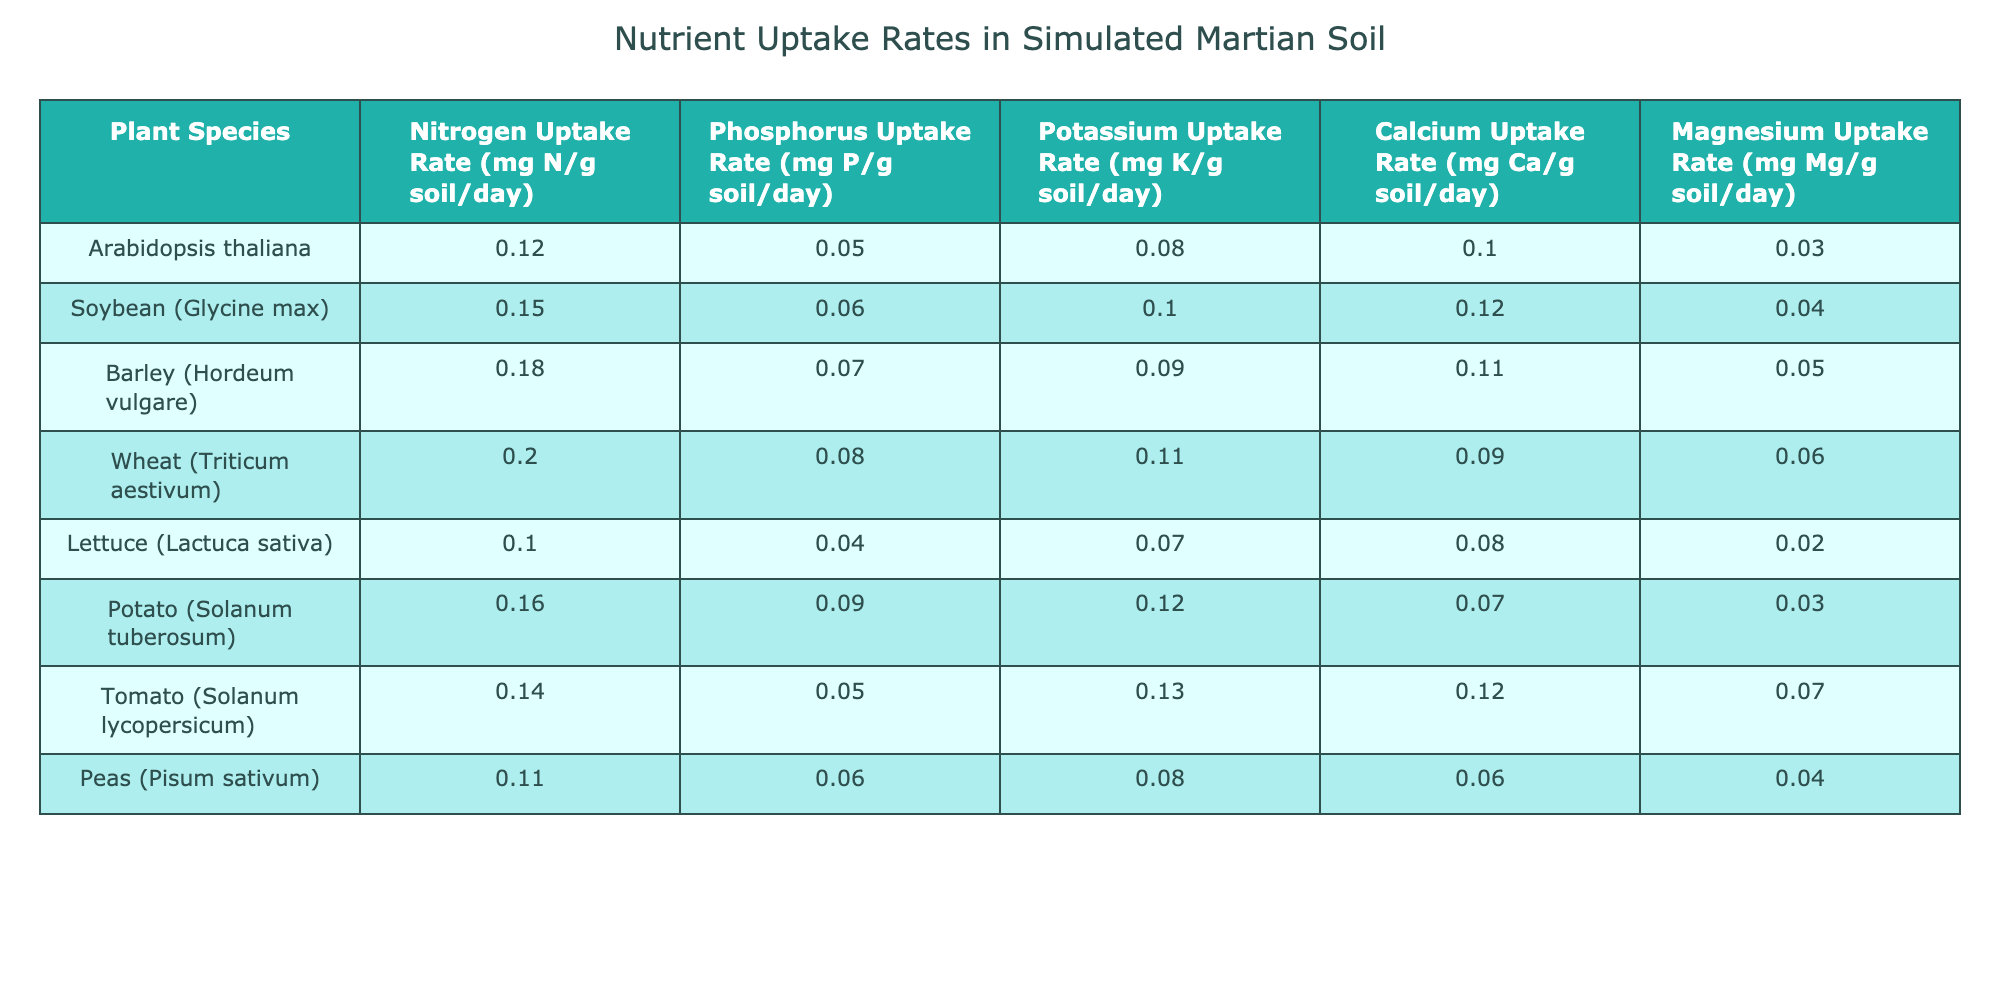What is the Nitrogen Uptake Rate for Wheat? The table lists the Nitrogen Uptake Rate for each plant species. For Wheat, the value provided is 0.20 mg N/g soil/day.
Answer: 0.20 mg N/g soil/day Which plant species has the highest Potassium Uptake Rate? By comparing the Potassium Uptake Rates in the table, Barley has the highest value at 0.09 mg K/g soil/day.
Answer: Barley What is the average Phosphorus Uptake Rate across all plant species? The Phosphorus Uptake Rate values are 0.05, 0.06, 0.07, 0.08, 0.04, 0.09, 0.05, and 0.06 mg P/g soil/day for the eight species. The total is 0.50 mg P/g soil/day, and dividing by 8 gives an average of 0.0625 mg P/g soil/day.
Answer: 0.0625 mg P/g soil/day Is the Calcium Uptake Rate for Tomato greater than that of Potato? The Calcium Uptake Rate for Tomato is 0.12 mg Ca/g soil/day, and for Potato, it is 0.07 mg Ca/g soil/day. Since 0.12 is greater than 0.07, the statement is true.
Answer: Yes If we combine the Nitrogen Uptake Rates of Soybean, Barley, and Potato, what is the total? The Nitrogen Uptake Rates for Soybean, Barley, and Potato are 0.15, 0.18, and 0.16 mg N/g soil/day, respectively. Summing these gives 0.15 + 0.18 + 0.16 = 0.49 mg N/g soil/day.
Answer: 0.49 mg N/g soil/day What is the difference in Magnesium Uptake Rate between Wheat and Potato? The Magnesium Uptake Rate for Wheat is 0.06 mg Mg/g soil/day and for Potato, it is 0.03 mg Mg/g soil/day. The difference is calculated as 0.06 - 0.03 = 0.03 mg Mg/g soil/day.
Answer: 0.03 mg Mg/g soil/day Do all plant species have a Nitrogen Uptake Rate greater than 0.10 mg N/g soil/day? The table shows that Arabidopsis thaliana and Peas have Nitrogen Uptake Rates of 0.12 and 0.11 mg N/g soil/day, respectively, which are greater than 0.10 mg N/g soil/day, but Lettuce only has 0.10 mg N/g soil/day, so the answer is no, not all.
Answer: No Which plant has the highest Magnesium Uptake Rate? The Magnesium Uptake Rates in the table are 0.03, 0.04, 0.05, 0.06, 0.02, 0.03, 0.07, and 0.04 mg Mg/g soil/day. Wheat has the highest rate at 0.06 mg Mg/g soil/day.
Answer: Wheat 